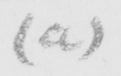Please transcribe the handwritten text in this image. ( a ) 